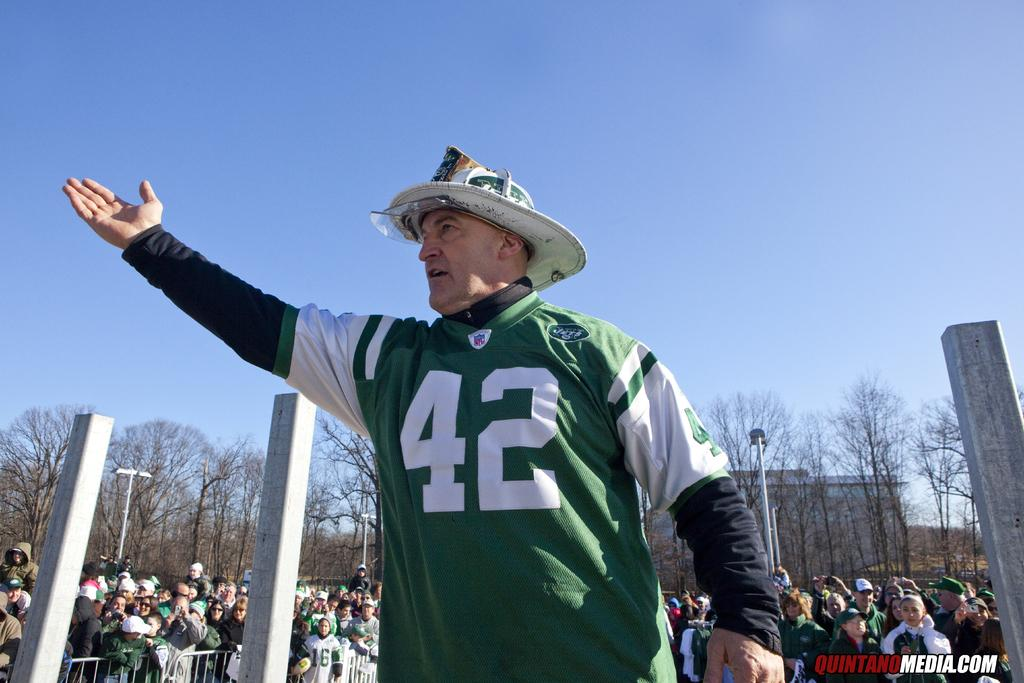Provide a one-sentence caption for the provided image. A middle-aged man in a firefighter's hat and a Jets NFL jersey is reaching to the sky outside on a clear day. 